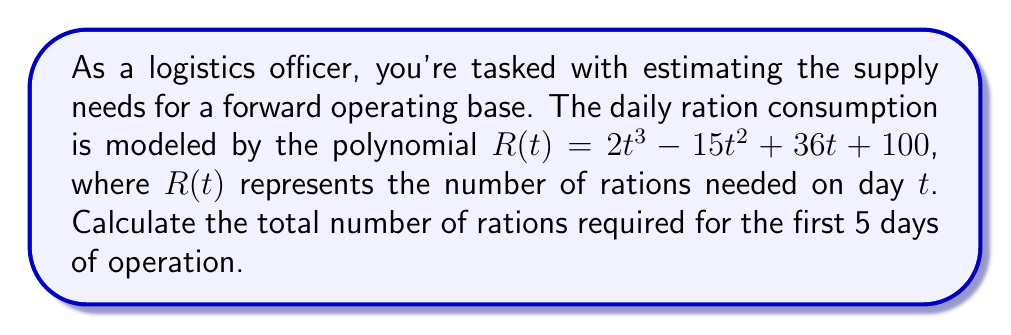Provide a solution to this math problem. To solve this problem, we need to calculate the sum of rations for each day from day 1 to day 5. Let's break it down step-by-step:

1) We need to evaluate $R(t)$ for $t = 1, 2, 3, 4, 5$ and then sum the results.

2) Let's calculate each day's ration requirement:

   Day 1: $R(1) = 2(1)^3 - 15(1)^2 + 36(1) + 100 = 2 - 15 + 36 + 100 = 123$ rations
   
   Day 2: $R(2) = 2(2)^3 - 15(2)^2 + 36(2) + 100 = 16 - 60 + 72 + 100 = 128$ rations
   
   Day 3: $R(3) = 2(3)^3 - 15(3)^2 + 36(3) + 100 = 54 - 135 + 108 + 100 = 127$ rations
   
   Day 4: $R(4) = 2(4)^3 - 15(4)^2 + 36(4) + 100 = 128 - 240 + 144 + 100 = 132$ rations
   
   Day 5: $R(5) = 2(5)^3 - 15(5)^2 + 36(5) + 100 = 250 - 375 + 180 + 100 = 155$ rations

3) Now, we sum up the rations for all 5 days:

   Total rations = $123 + 128 + 127 + 132 + 155 = 665$ rations

Therefore, the total number of rations required for the first 5 days of operation is 665.
Answer: 665 rations 